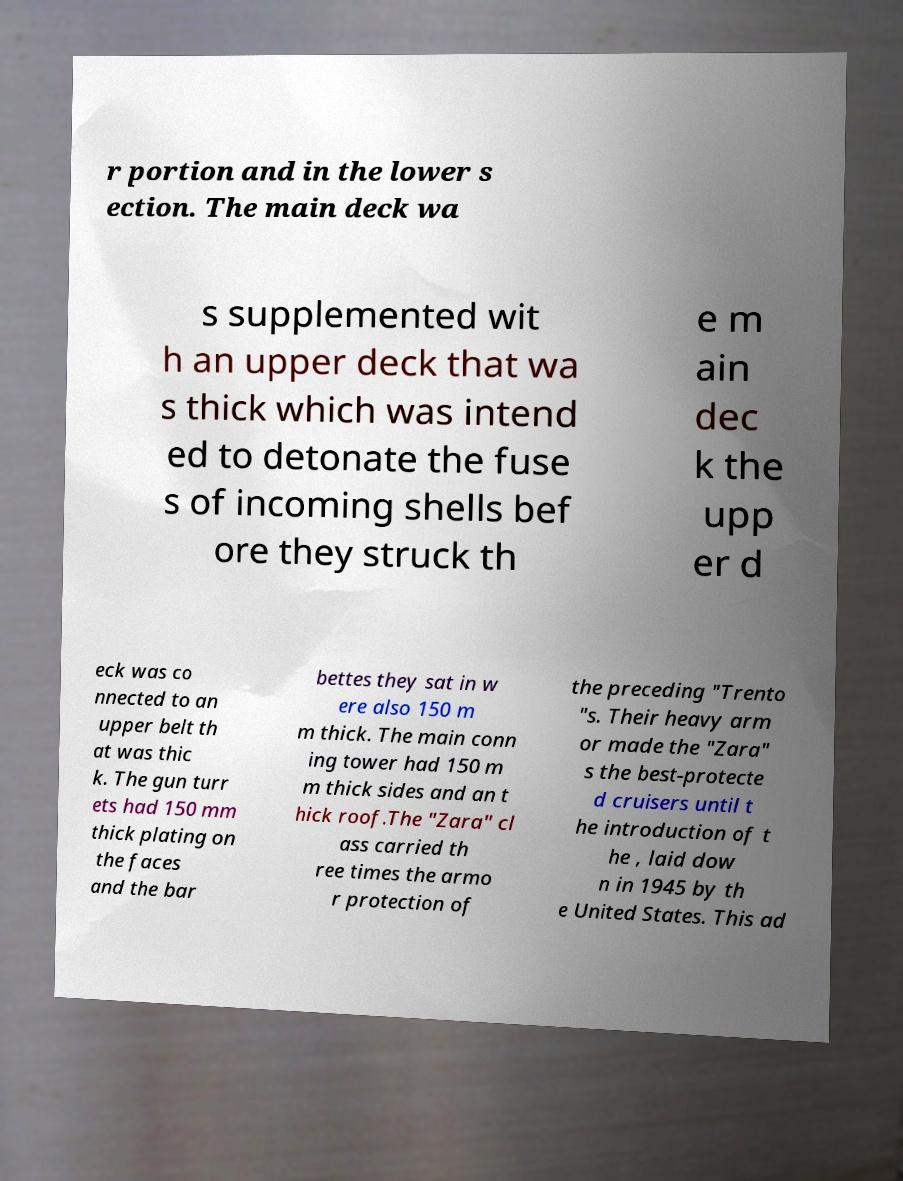There's text embedded in this image that I need extracted. Can you transcribe it verbatim? r portion and in the lower s ection. The main deck wa s supplemented wit h an upper deck that wa s thick which was intend ed to detonate the fuse s of incoming shells bef ore they struck th e m ain dec k the upp er d eck was co nnected to an upper belt th at was thic k. The gun turr ets had 150 mm thick plating on the faces and the bar bettes they sat in w ere also 150 m m thick. The main conn ing tower had 150 m m thick sides and an t hick roof.The "Zara" cl ass carried th ree times the armo r protection of the preceding "Trento "s. Their heavy arm or made the "Zara" s the best-protecte d cruisers until t he introduction of t he , laid dow n in 1945 by th e United States. This ad 